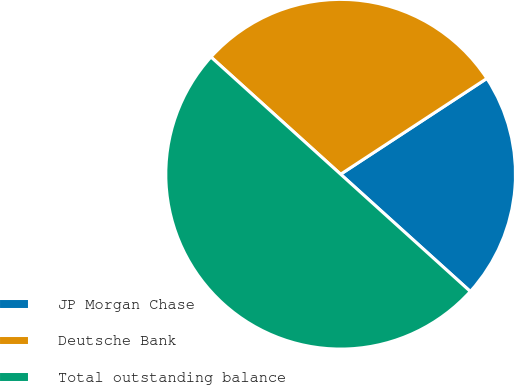<chart> <loc_0><loc_0><loc_500><loc_500><pie_chart><fcel>JP Morgan Chase<fcel>Deutsche Bank<fcel>Total outstanding balance<nl><fcel>20.93%<fcel>29.07%<fcel>50.0%<nl></chart> 